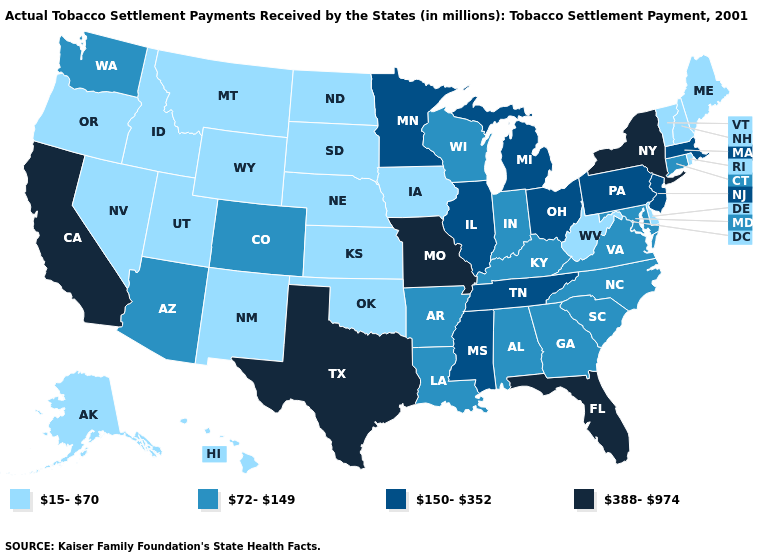What is the lowest value in the USA?
Quick response, please. 15-70. Which states have the lowest value in the USA?
Answer briefly. Alaska, Delaware, Hawaii, Idaho, Iowa, Kansas, Maine, Montana, Nebraska, Nevada, New Hampshire, New Mexico, North Dakota, Oklahoma, Oregon, Rhode Island, South Dakota, Utah, Vermont, West Virginia, Wyoming. Among the states that border Iowa , which have the lowest value?
Concise answer only. Nebraska, South Dakota. Name the states that have a value in the range 150-352?
Keep it brief. Illinois, Massachusetts, Michigan, Minnesota, Mississippi, New Jersey, Ohio, Pennsylvania, Tennessee. Among the states that border California , does Arizona have the lowest value?
Give a very brief answer. No. Which states have the highest value in the USA?
Concise answer only. California, Florida, Missouri, New York, Texas. Which states have the highest value in the USA?
Concise answer only. California, Florida, Missouri, New York, Texas. Name the states that have a value in the range 388-974?
Be succinct. California, Florida, Missouri, New York, Texas. Does Maine have a lower value than Illinois?
Keep it brief. Yes. What is the lowest value in the MidWest?
Short answer required. 15-70. Name the states that have a value in the range 150-352?
Quick response, please. Illinois, Massachusetts, Michigan, Minnesota, Mississippi, New Jersey, Ohio, Pennsylvania, Tennessee. Name the states that have a value in the range 15-70?
Give a very brief answer. Alaska, Delaware, Hawaii, Idaho, Iowa, Kansas, Maine, Montana, Nebraska, Nevada, New Hampshire, New Mexico, North Dakota, Oklahoma, Oregon, Rhode Island, South Dakota, Utah, Vermont, West Virginia, Wyoming. Does Tennessee have a higher value than Kansas?
Quick response, please. Yes. How many symbols are there in the legend?
Answer briefly. 4. What is the lowest value in the USA?
Keep it brief. 15-70. 